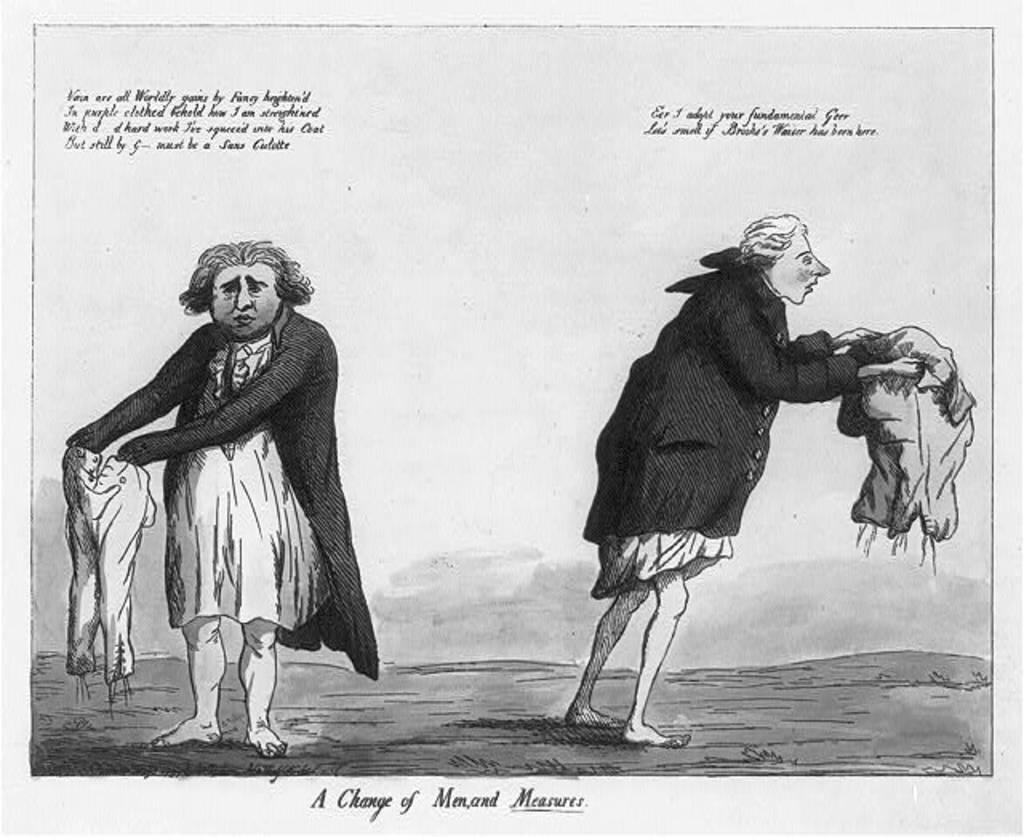What is present in the image? There is a poster in the image. What is depicted on the poster? The poster contains two people standing. What type of suggestion is being made by the people on the poster? There is no suggestion being made by the people on the poster; they are simply standing. 